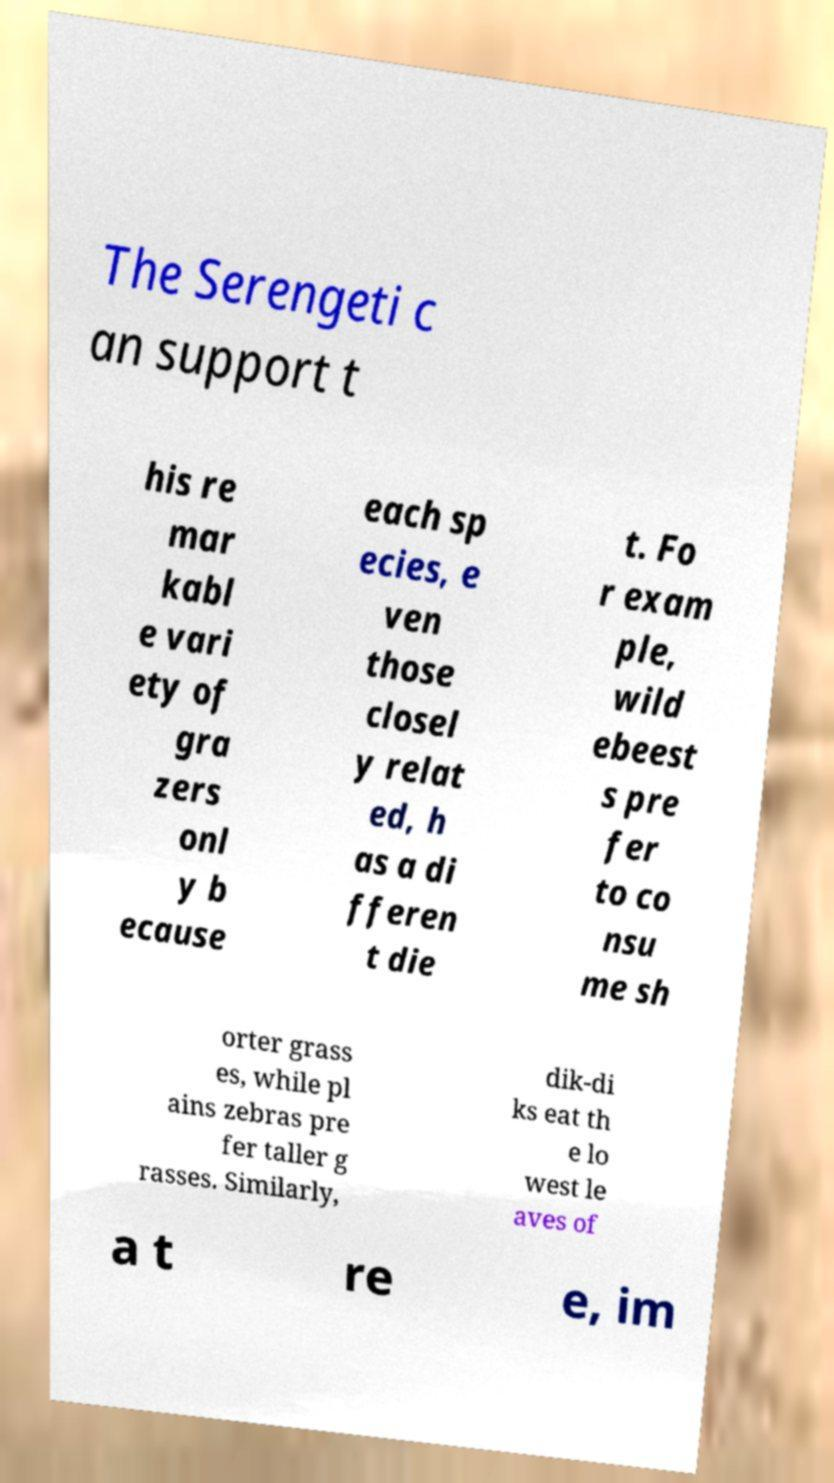Could you extract and type out the text from this image? The Serengeti c an support t his re mar kabl e vari ety of gra zers onl y b ecause each sp ecies, e ven those closel y relat ed, h as a di fferen t die t. Fo r exam ple, wild ebeest s pre fer to co nsu me sh orter grass es, while pl ains zebras pre fer taller g rasses. Similarly, dik-di ks eat th e lo west le aves of a t re e, im 